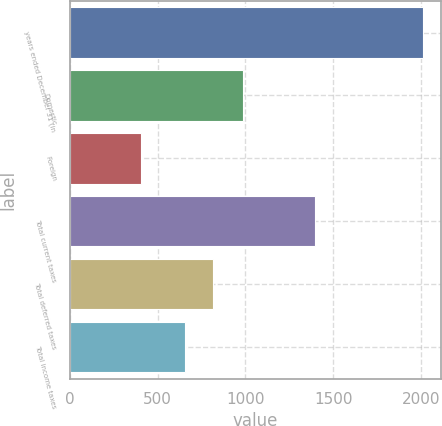Convert chart to OTSL. <chart><loc_0><loc_0><loc_500><loc_500><bar_chart><fcel>years ended December 31 (in<fcel>Domestic<fcel>Foreign<fcel>Total current taxes<fcel>Total deferred taxes<fcel>Total income taxes<nl><fcel>2010<fcel>987<fcel>408<fcel>1395<fcel>818.2<fcel>658<nl></chart> 